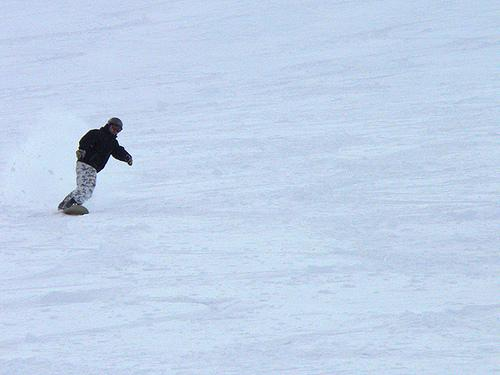Briefly mention the person's attire in relation to their activity. The snowboarder is dressed in appropriate snowboarding gear, including a jacket, pants, gloves, and goggles. Describe the location and environment of the image. The image shows a snowboarder on a snowy mountainside, leaving tracks in the snow as they descend. Explain briefly the individual's appearance with respect to the snowy environment. The person is well-dressed for snowboarding, with warm clothing and protective gear, complementing the snowy surroundings. Highlight the colors of the main objects worn by the person in the image. The person is wearing a black coat, white pants with black design, and orange goggles. Mention a distinguishing feature of the person's pants in the image. The person's white pants have a black design on them. Mention the key activity depicted in the image and the person taking part in it. A young man is actively participating in snowboarding down a snow-covered mountain. Provide a brief overview of the person's outfit in the image. The person is wearing a black jacket, white pants with a black design, gloves, goggles, and black shoes. Give a summary of the primary action taking place in the image. A man is riding a snowboard down a snowy mountain slope. Describe the individual's headwear and eyewear in the image. The snowboarder is wearing a knit cap and orange goggles. Mention the type of sport the person in the image is involved in. The person is engaged in the winter sport of snowboarding. 